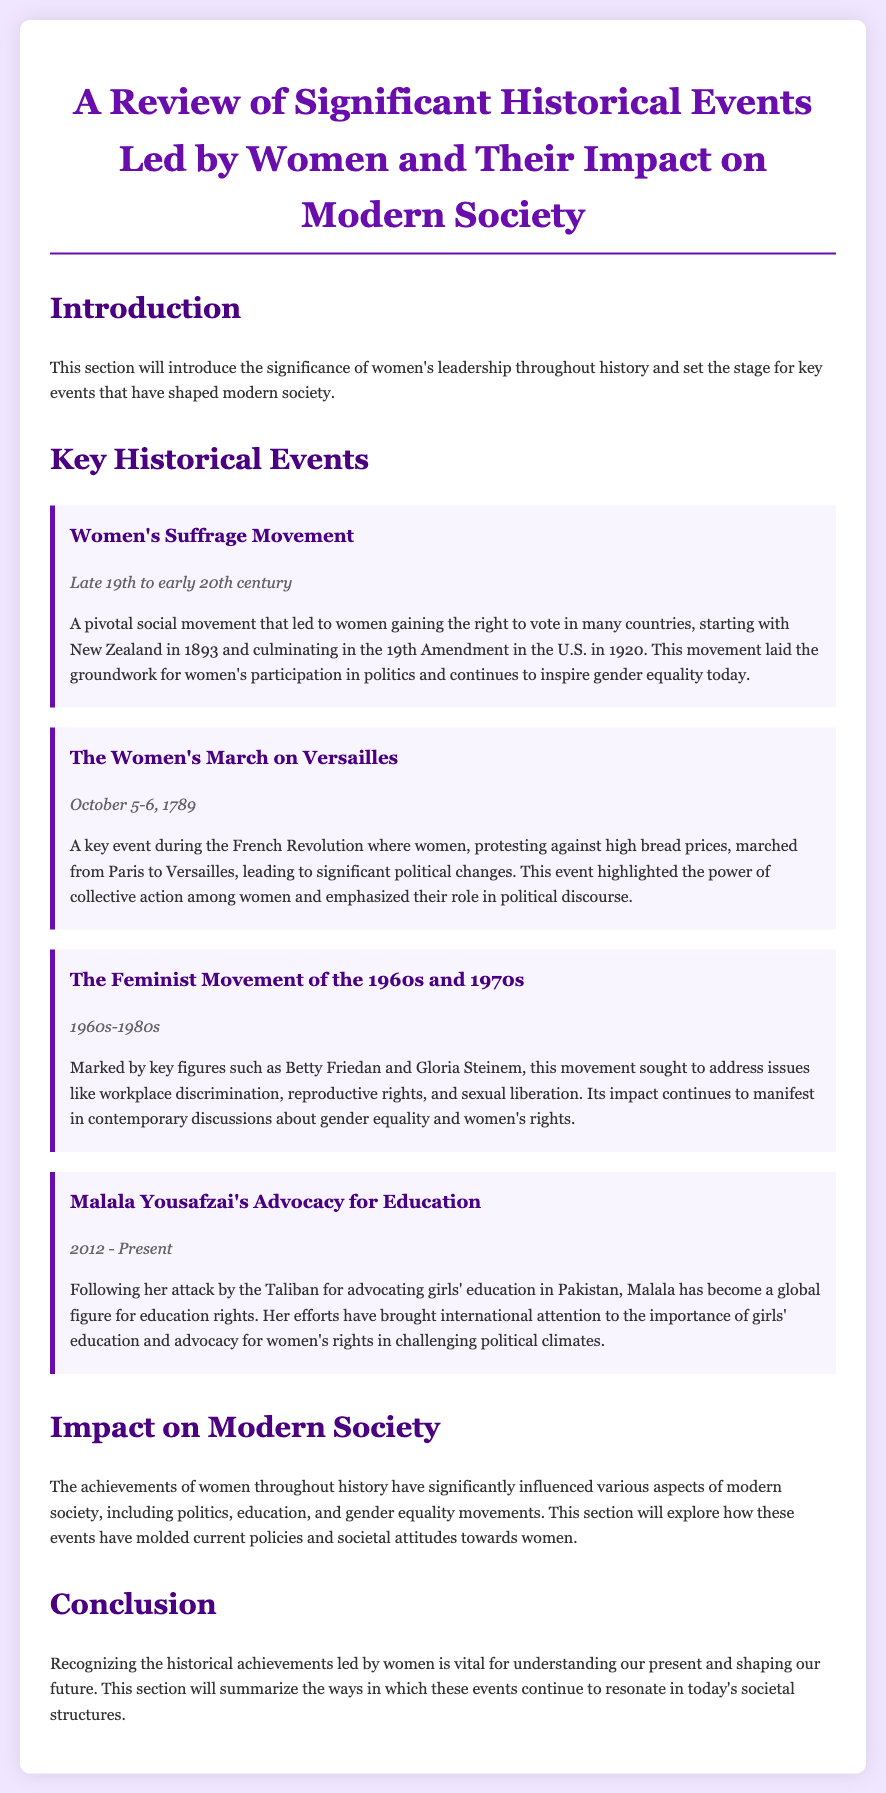what significant social movement led to women's right to vote? The document mentions the Women's Suffrage Movement as the pivotal social movement that led to women's right to vote.
Answer: Women's Suffrage Movement when did the Women's March on Versailles occur? The document states that the Women's March on Versailles took place on October 5-6, 1789.
Answer: October 5-6, 1789 who is a key figure associated with the Feminist Movement of the 1960s and 1970s? The document highlights Betty Friedan as a key figure associated with this movement.
Answer: Betty Friedan what major event did Malala Yousafzai become globally recognized for? According to the document, Malala Yousafzai became a global figure for her advocacy for education rights after her attack by the Taliban.
Answer: Advocacy for education how did the Women's Suffrage Movement impact modern society? The document states that this movement laid the groundwork for women's participation in politics and inspires gender equality today.
Answer: Women's participation in politics which two movements are mentioned in context with gender equality? The document cites the Women's Suffrage Movement and the Feminist Movement of the 1960s and 1970s as movements related to gender equality.
Answer: Women's Suffrage Movement and Feminist Movement what is the main purpose of the document? The document aims to review significant historical events led by women and their impact on modern society.
Answer: Review significant historical events what will the conclusion section summarize? The conclusion section will summarize how the achievements of women continue to resonate in today's societal structures.
Answer: Achievements of women continue to resonate 